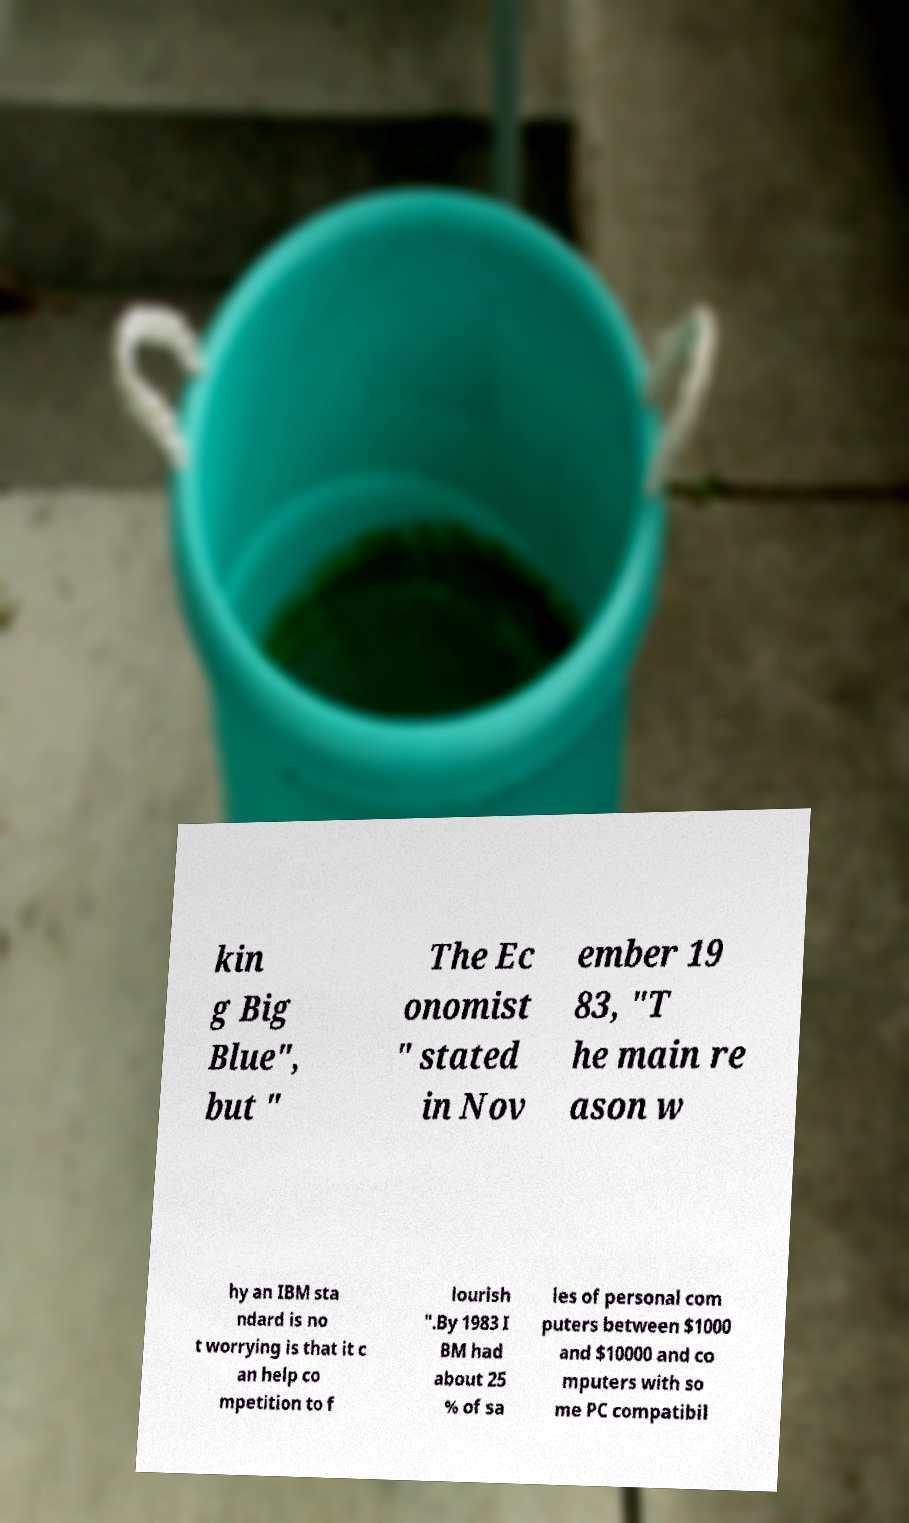Could you extract and type out the text from this image? kin g Big Blue", but " The Ec onomist " stated in Nov ember 19 83, "T he main re ason w hy an IBM sta ndard is no t worrying is that it c an help co mpetition to f lourish ".By 1983 I BM had about 25 % of sa les of personal com puters between $1000 and $10000 and co mputers with so me PC compatibil 